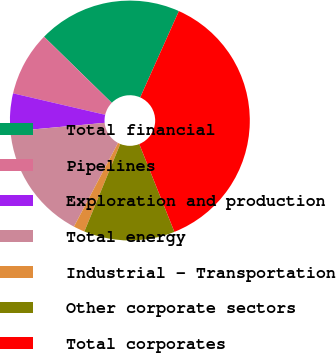Convert chart to OTSL. <chart><loc_0><loc_0><loc_500><loc_500><pie_chart><fcel>Total financial<fcel>Pipelines<fcel>Exploration and production<fcel>Total energy<fcel>Industrial - Transportation<fcel>Other corporate sectors<fcel>Total corporates<nl><fcel>19.39%<fcel>8.67%<fcel>5.1%<fcel>15.82%<fcel>1.53%<fcel>12.25%<fcel>37.24%<nl></chart> 